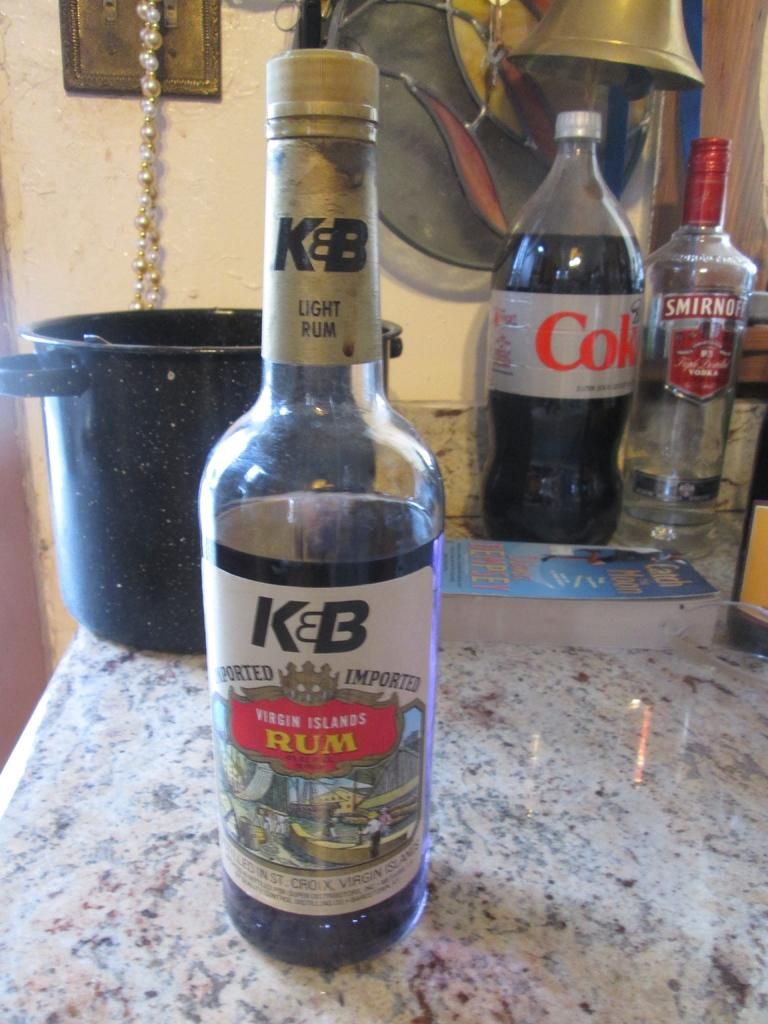<image>
Provide a brief description of the given image. A bottle of K and B Virgin Islands rum on a marble counter top. 